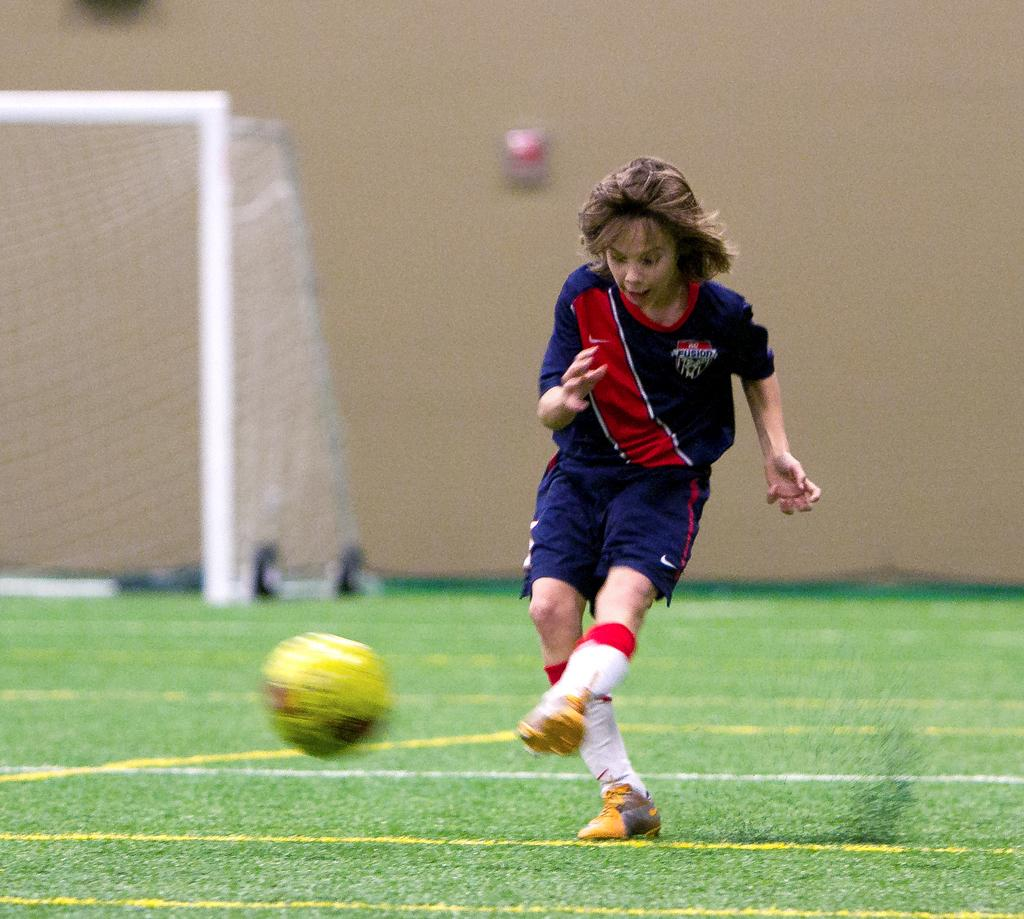What activity is the person in the image engaged in? The person is playing football in the image. What is the position of the person in the image? The person is on the ground. What equipment is present in the image related to football? There is a goalkeeper pole and net in the image. Can you see any mice running around in the garden in the image? There is no garden or mice present in the image; it features a person playing football with a goalkeeper pole and net. 